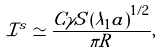<formula> <loc_0><loc_0><loc_500><loc_500>\mathcal { I } ^ { s } \simeq \frac { C \gamma S \left ( \lambda _ { 1 } a \right ) ^ { 1 / 2 } } { \pi R } ,</formula> 